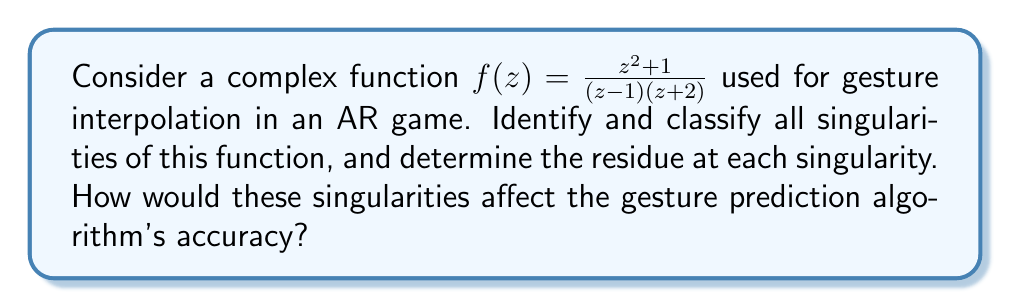Show me your answer to this math problem. To analyze the singularities of the given function $f(z) = \frac{z^2 + 1}{(z-1)(z+2)}$, we need to follow these steps:

1. Identify the singularities:
   The singularities occur where the denominator of the function is zero. In this case:
   $(z-1)(z+2) = 0$
   This gives us two singularities: $z = 1$ and $z = -2$

2. Classify the singularities:
   To classify these singularities, we need to examine the behavior of the function near each point.

   a) For $z = 1$:
      Let's rewrite the function as:
      $$f(z) = \frac{z^2 + 1}{(z-1)(z+2)} = \frac{(z+1)(z-1) + 2}{(z-1)(z+2)} = \frac{z+1}{z+2} + \frac{2}{(z-1)(z+2)}$$
      The first term is analytic at $z = 1$, while the second term has a simple pole at $z = 1$.
      Therefore, $z = 1$ is a simple pole.

   b) For $z = -2$:
      We can rewrite the function as:
      $$f(z) = \frac{z^2 + 1}{(z-1)(z+2)} = \frac{(z+2)(z-2) + 5}{(z-1)(z+2)} = \frac{z-2}{z-1} + \frac{5}{(z-1)(z+2)}$$
      The first term is analytic at $z = -2$, while the second term has a simple pole at $z = -2$.
      Therefore, $z = -2$ is also a simple pole.

3. Calculate the residues:
   a) For $z = 1$:
      $$\text{Res}(f, 1) = \lim_{z \to 1} (z-1)f(z) = \lim_{z \to 1} \frac{z^2 + 1}{z+2} = \frac{2}{3}$$

   b) For $z = -2$:
      $$\text{Res}(f, -2) = \lim_{z \to -2} (z+2)f(z) = \lim_{z \to -2} \frac{z^2 + 1}{z-1} = \frac{5}{-3} = -\frac{5}{3}$$

The singularities would affect the gesture prediction algorithm's accuracy in the following ways:

1. Near the singularities (z = 1 and z = -2), the function values change rapidly, which could lead to unstable or erratic behavior in the gesture interpolation.
2. The residues at these singularities indicate the strength of the poles. The larger residue at z = -2 suggests that this singularity might have a more significant impact on the interpolation.
3. In practical implementation, the algorithm should avoid calculations near these singularities to maintain accuracy and stability in gesture prediction.
4. The developer might need to implement special handling or smoothing techniques when the input values approach these singularities to ensure consistent and accurate gesture recognition.
Answer: The function $f(z) = \frac{z^2 + 1}{(z-1)(z+2)}$ has two simple poles:
1. At $z = 1$ with residue $\frac{2}{3}$
2. At $z = -2$ with residue $-\frac{5}{3}$
These singularities can cause rapid changes in function values nearby, potentially leading to instability in gesture interpolation and requiring special handling in the prediction algorithm. 